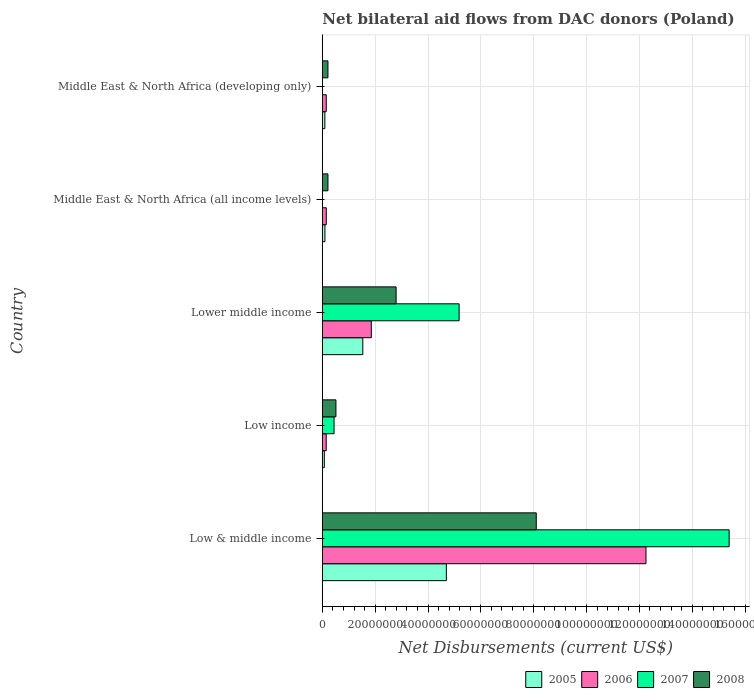Are the number of bars on each tick of the Y-axis equal?
Provide a succinct answer. No. How many bars are there on the 4th tick from the bottom?
Keep it short and to the point. 3. What is the label of the 2nd group of bars from the top?
Give a very brief answer. Middle East & North Africa (all income levels). In how many cases, is the number of bars for a given country not equal to the number of legend labels?
Your response must be concise. 2. What is the net bilateral aid flows in 2008 in Low & middle income?
Give a very brief answer. 8.10e+07. Across all countries, what is the maximum net bilateral aid flows in 2006?
Make the answer very short. 1.23e+08. What is the total net bilateral aid flows in 2005 in the graph?
Give a very brief answer. 6.50e+07. What is the difference between the net bilateral aid flows in 2005 in Low & middle income and that in Low income?
Make the answer very short. 4.62e+07. What is the difference between the net bilateral aid flows in 2008 in Low income and the net bilateral aid flows in 2005 in Low & middle income?
Your answer should be compact. -4.18e+07. What is the average net bilateral aid flows in 2007 per country?
Your answer should be very brief. 4.20e+07. What is the difference between the net bilateral aid flows in 2007 and net bilateral aid flows in 2008 in Low & middle income?
Offer a terse response. 7.30e+07. In how many countries, is the net bilateral aid flows in 2007 greater than 28000000 US$?
Your response must be concise. 2. What is the ratio of the net bilateral aid flows in 2006 in Low & middle income to that in Middle East & North Africa (all income levels)?
Offer a very short reply. 81.67. What is the difference between the highest and the second highest net bilateral aid flows in 2005?
Your answer should be compact. 3.16e+07. What is the difference between the highest and the lowest net bilateral aid flows in 2005?
Give a very brief answer. 4.62e+07. Is the sum of the net bilateral aid flows in 2008 in Low income and Middle East & North Africa (developing only) greater than the maximum net bilateral aid flows in 2007 across all countries?
Provide a succinct answer. No. Does the graph contain any zero values?
Provide a succinct answer. Yes. Does the graph contain grids?
Your response must be concise. Yes. What is the title of the graph?
Give a very brief answer. Net bilateral aid flows from DAC donors (Poland). Does "1963" appear as one of the legend labels in the graph?
Ensure brevity in your answer.  No. What is the label or title of the X-axis?
Keep it short and to the point. Net Disbursements (current US$). What is the Net Disbursements (current US$) of 2005 in Low & middle income?
Offer a terse response. 4.69e+07. What is the Net Disbursements (current US$) in 2006 in Low & middle income?
Your answer should be compact. 1.23e+08. What is the Net Disbursements (current US$) in 2007 in Low & middle income?
Provide a succinct answer. 1.54e+08. What is the Net Disbursements (current US$) in 2008 in Low & middle income?
Ensure brevity in your answer.  8.10e+07. What is the Net Disbursements (current US$) in 2005 in Low income?
Offer a terse response. 7.50e+05. What is the Net Disbursements (current US$) of 2006 in Low income?
Provide a short and direct response. 1.47e+06. What is the Net Disbursements (current US$) of 2007 in Low income?
Ensure brevity in your answer.  4.44e+06. What is the Net Disbursements (current US$) in 2008 in Low income?
Provide a short and direct response. 5.15e+06. What is the Net Disbursements (current US$) in 2005 in Lower middle income?
Make the answer very short. 1.53e+07. What is the Net Disbursements (current US$) of 2006 in Lower middle income?
Give a very brief answer. 1.85e+07. What is the Net Disbursements (current US$) of 2007 in Lower middle income?
Make the answer very short. 5.18e+07. What is the Net Disbursements (current US$) of 2008 in Lower middle income?
Ensure brevity in your answer.  2.79e+07. What is the Net Disbursements (current US$) in 2005 in Middle East & North Africa (all income levels)?
Offer a very short reply. 9.90e+05. What is the Net Disbursements (current US$) of 2006 in Middle East & North Africa (all income levels)?
Offer a very short reply. 1.50e+06. What is the Net Disbursements (current US$) of 2007 in Middle East & North Africa (all income levels)?
Offer a very short reply. 0. What is the Net Disbursements (current US$) in 2008 in Middle East & North Africa (all income levels)?
Ensure brevity in your answer.  2.13e+06. What is the Net Disbursements (current US$) of 2005 in Middle East & North Africa (developing only)?
Keep it short and to the point. 9.60e+05. What is the Net Disbursements (current US$) of 2006 in Middle East & North Africa (developing only)?
Offer a terse response. 1.49e+06. What is the Net Disbursements (current US$) in 2008 in Middle East & North Africa (developing only)?
Your answer should be compact. 2.13e+06. Across all countries, what is the maximum Net Disbursements (current US$) in 2005?
Keep it short and to the point. 4.69e+07. Across all countries, what is the maximum Net Disbursements (current US$) of 2006?
Give a very brief answer. 1.23e+08. Across all countries, what is the maximum Net Disbursements (current US$) of 2007?
Offer a terse response. 1.54e+08. Across all countries, what is the maximum Net Disbursements (current US$) of 2008?
Provide a short and direct response. 8.10e+07. Across all countries, what is the minimum Net Disbursements (current US$) of 2005?
Your answer should be compact. 7.50e+05. Across all countries, what is the minimum Net Disbursements (current US$) of 2006?
Provide a short and direct response. 1.47e+06. Across all countries, what is the minimum Net Disbursements (current US$) of 2007?
Your answer should be very brief. 0. Across all countries, what is the minimum Net Disbursements (current US$) in 2008?
Your response must be concise. 2.13e+06. What is the total Net Disbursements (current US$) in 2005 in the graph?
Your response must be concise. 6.50e+07. What is the total Net Disbursements (current US$) of 2006 in the graph?
Offer a very short reply. 1.46e+08. What is the total Net Disbursements (current US$) of 2007 in the graph?
Offer a very short reply. 2.10e+08. What is the total Net Disbursements (current US$) of 2008 in the graph?
Ensure brevity in your answer.  1.18e+08. What is the difference between the Net Disbursements (current US$) of 2005 in Low & middle income and that in Low income?
Make the answer very short. 4.62e+07. What is the difference between the Net Disbursements (current US$) of 2006 in Low & middle income and that in Low income?
Offer a terse response. 1.21e+08. What is the difference between the Net Disbursements (current US$) of 2007 in Low & middle income and that in Low income?
Your answer should be compact. 1.50e+08. What is the difference between the Net Disbursements (current US$) of 2008 in Low & middle income and that in Low income?
Your response must be concise. 7.58e+07. What is the difference between the Net Disbursements (current US$) of 2005 in Low & middle income and that in Lower middle income?
Your answer should be compact. 3.16e+07. What is the difference between the Net Disbursements (current US$) in 2006 in Low & middle income and that in Lower middle income?
Your response must be concise. 1.04e+08. What is the difference between the Net Disbursements (current US$) in 2007 in Low & middle income and that in Lower middle income?
Ensure brevity in your answer.  1.02e+08. What is the difference between the Net Disbursements (current US$) of 2008 in Low & middle income and that in Lower middle income?
Offer a terse response. 5.30e+07. What is the difference between the Net Disbursements (current US$) in 2005 in Low & middle income and that in Middle East & North Africa (all income levels)?
Provide a short and direct response. 4.60e+07. What is the difference between the Net Disbursements (current US$) in 2006 in Low & middle income and that in Middle East & North Africa (all income levels)?
Offer a terse response. 1.21e+08. What is the difference between the Net Disbursements (current US$) of 2008 in Low & middle income and that in Middle East & North Africa (all income levels)?
Provide a short and direct response. 7.88e+07. What is the difference between the Net Disbursements (current US$) in 2005 in Low & middle income and that in Middle East & North Africa (developing only)?
Your answer should be very brief. 4.60e+07. What is the difference between the Net Disbursements (current US$) in 2006 in Low & middle income and that in Middle East & North Africa (developing only)?
Your response must be concise. 1.21e+08. What is the difference between the Net Disbursements (current US$) of 2008 in Low & middle income and that in Middle East & North Africa (developing only)?
Make the answer very short. 7.88e+07. What is the difference between the Net Disbursements (current US$) in 2005 in Low income and that in Lower middle income?
Give a very brief answer. -1.46e+07. What is the difference between the Net Disbursements (current US$) in 2006 in Low income and that in Lower middle income?
Your answer should be very brief. -1.71e+07. What is the difference between the Net Disbursements (current US$) in 2007 in Low income and that in Lower middle income?
Provide a succinct answer. -4.73e+07. What is the difference between the Net Disbursements (current US$) in 2008 in Low income and that in Lower middle income?
Offer a very short reply. -2.28e+07. What is the difference between the Net Disbursements (current US$) in 2005 in Low income and that in Middle East & North Africa (all income levels)?
Provide a short and direct response. -2.40e+05. What is the difference between the Net Disbursements (current US$) in 2006 in Low income and that in Middle East & North Africa (all income levels)?
Provide a short and direct response. -3.00e+04. What is the difference between the Net Disbursements (current US$) in 2008 in Low income and that in Middle East & North Africa (all income levels)?
Your answer should be very brief. 3.02e+06. What is the difference between the Net Disbursements (current US$) of 2008 in Low income and that in Middle East & North Africa (developing only)?
Provide a short and direct response. 3.02e+06. What is the difference between the Net Disbursements (current US$) of 2005 in Lower middle income and that in Middle East & North Africa (all income levels)?
Your response must be concise. 1.43e+07. What is the difference between the Net Disbursements (current US$) in 2006 in Lower middle income and that in Middle East & North Africa (all income levels)?
Ensure brevity in your answer.  1.70e+07. What is the difference between the Net Disbursements (current US$) of 2008 in Lower middle income and that in Middle East & North Africa (all income levels)?
Provide a succinct answer. 2.58e+07. What is the difference between the Net Disbursements (current US$) of 2005 in Lower middle income and that in Middle East & North Africa (developing only)?
Offer a very short reply. 1.44e+07. What is the difference between the Net Disbursements (current US$) of 2006 in Lower middle income and that in Middle East & North Africa (developing only)?
Provide a succinct answer. 1.70e+07. What is the difference between the Net Disbursements (current US$) of 2008 in Lower middle income and that in Middle East & North Africa (developing only)?
Your answer should be compact. 2.58e+07. What is the difference between the Net Disbursements (current US$) in 2005 in Middle East & North Africa (all income levels) and that in Middle East & North Africa (developing only)?
Offer a terse response. 3.00e+04. What is the difference between the Net Disbursements (current US$) in 2006 in Middle East & North Africa (all income levels) and that in Middle East & North Africa (developing only)?
Your answer should be very brief. 10000. What is the difference between the Net Disbursements (current US$) in 2005 in Low & middle income and the Net Disbursements (current US$) in 2006 in Low income?
Offer a terse response. 4.55e+07. What is the difference between the Net Disbursements (current US$) in 2005 in Low & middle income and the Net Disbursements (current US$) in 2007 in Low income?
Provide a short and direct response. 4.25e+07. What is the difference between the Net Disbursements (current US$) of 2005 in Low & middle income and the Net Disbursements (current US$) of 2008 in Low income?
Your answer should be very brief. 4.18e+07. What is the difference between the Net Disbursements (current US$) of 2006 in Low & middle income and the Net Disbursements (current US$) of 2007 in Low income?
Your answer should be compact. 1.18e+08. What is the difference between the Net Disbursements (current US$) in 2006 in Low & middle income and the Net Disbursements (current US$) in 2008 in Low income?
Make the answer very short. 1.17e+08. What is the difference between the Net Disbursements (current US$) in 2007 in Low & middle income and the Net Disbursements (current US$) in 2008 in Low income?
Offer a very short reply. 1.49e+08. What is the difference between the Net Disbursements (current US$) in 2005 in Low & middle income and the Net Disbursements (current US$) in 2006 in Lower middle income?
Your answer should be very brief. 2.84e+07. What is the difference between the Net Disbursements (current US$) of 2005 in Low & middle income and the Net Disbursements (current US$) of 2007 in Lower middle income?
Your answer should be compact. -4.84e+06. What is the difference between the Net Disbursements (current US$) of 2005 in Low & middle income and the Net Disbursements (current US$) of 2008 in Lower middle income?
Provide a short and direct response. 1.90e+07. What is the difference between the Net Disbursements (current US$) in 2006 in Low & middle income and the Net Disbursements (current US$) in 2007 in Lower middle income?
Keep it short and to the point. 7.07e+07. What is the difference between the Net Disbursements (current US$) of 2006 in Low & middle income and the Net Disbursements (current US$) of 2008 in Lower middle income?
Give a very brief answer. 9.46e+07. What is the difference between the Net Disbursements (current US$) in 2007 in Low & middle income and the Net Disbursements (current US$) in 2008 in Lower middle income?
Make the answer very short. 1.26e+08. What is the difference between the Net Disbursements (current US$) of 2005 in Low & middle income and the Net Disbursements (current US$) of 2006 in Middle East & North Africa (all income levels)?
Provide a short and direct response. 4.54e+07. What is the difference between the Net Disbursements (current US$) of 2005 in Low & middle income and the Net Disbursements (current US$) of 2008 in Middle East & North Africa (all income levels)?
Provide a short and direct response. 4.48e+07. What is the difference between the Net Disbursements (current US$) in 2006 in Low & middle income and the Net Disbursements (current US$) in 2008 in Middle East & North Africa (all income levels)?
Your answer should be compact. 1.20e+08. What is the difference between the Net Disbursements (current US$) in 2007 in Low & middle income and the Net Disbursements (current US$) in 2008 in Middle East & North Africa (all income levels)?
Offer a terse response. 1.52e+08. What is the difference between the Net Disbursements (current US$) of 2005 in Low & middle income and the Net Disbursements (current US$) of 2006 in Middle East & North Africa (developing only)?
Your response must be concise. 4.54e+07. What is the difference between the Net Disbursements (current US$) in 2005 in Low & middle income and the Net Disbursements (current US$) in 2008 in Middle East & North Africa (developing only)?
Offer a very short reply. 4.48e+07. What is the difference between the Net Disbursements (current US$) in 2006 in Low & middle income and the Net Disbursements (current US$) in 2008 in Middle East & North Africa (developing only)?
Offer a very short reply. 1.20e+08. What is the difference between the Net Disbursements (current US$) of 2007 in Low & middle income and the Net Disbursements (current US$) of 2008 in Middle East & North Africa (developing only)?
Give a very brief answer. 1.52e+08. What is the difference between the Net Disbursements (current US$) of 2005 in Low income and the Net Disbursements (current US$) of 2006 in Lower middle income?
Offer a very short reply. -1.78e+07. What is the difference between the Net Disbursements (current US$) of 2005 in Low income and the Net Disbursements (current US$) of 2007 in Lower middle income?
Ensure brevity in your answer.  -5.10e+07. What is the difference between the Net Disbursements (current US$) of 2005 in Low income and the Net Disbursements (current US$) of 2008 in Lower middle income?
Provide a short and direct response. -2.72e+07. What is the difference between the Net Disbursements (current US$) of 2006 in Low income and the Net Disbursements (current US$) of 2007 in Lower middle income?
Keep it short and to the point. -5.03e+07. What is the difference between the Net Disbursements (current US$) in 2006 in Low income and the Net Disbursements (current US$) in 2008 in Lower middle income?
Give a very brief answer. -2.65e+07. What is the difference between the Net Disbursements (current US$) of 2007 in Low income and the Net Disbursements (current US$) of 2008 in Lower middle income?
Your response must be concise. -2.35e+07. What is the difference between the Net Disbursements (current US$) of 2005 in Low income and the Net Disbursements (current US$) of 2006 in Middle East & North Africa (all income levels)?
Your answer should be compact. -7.50e+05. What is the difference between the Net Disbursements (current US$) of 2005 in Low income and the Net Disbursements (current US$) of 2008 in Middle East & North Africa (all income levels)?
Offer a very short reply. -1.38e+06. What is the difference between the Net Disbursements (current US$) in 2006 in Low income and the Net Disbursements (current US$) in 2008 in Middle East & North Africa (all income levels)?
Provide a succinct answer. -6.60e+05. What is the difference between the Net Disbursements (current US$) of 2007 in Low income and the Net Disbursements (current US$) of 2008 in Middle East & North Africa (all income levels)?
Provide a succinct answer. 2.31e+06. What is the difference between the Net Disbursements (current US$) of 2005 in Low income and the Net Disbursements (current US$) of 2006 in Middle East & North Africa (developing only)?
Your answer should be compact. -7.40e+05. What is the difference between the Net Disbursements (current US$) in 2005 in Low income and the Net Disbursements (current US$) in 2008 in Middle East & North Africa (developing only)?
Keep it short and to the point. -1.38e+06. What is the difference between the Net Disbursements (current US$) of 2006 in Low income and the Net Disbursements (current US$) of 2008 in Middle East & North Africa (developing only)?
Provide a short and direct response. -6.60e+05. What is the difference between the Net Disbursements (current US$) in 2007 in Low income and the Net Disbursements (current US$) in 2008 in Middle East & North Africa (developing only)?
Your response must be concise. 2.31e+06. What is the difference between the Net Disbursements (current US$) of 2005 in Lower middle income and the Net Disbursements (current US$) of 2006 in Middle East & North Africa (all income levels)?
Keep it short and to the point. 1.38e+07. What is the difference between the Net Disbursements (current US$) in 2005 in Lower middle income and the Net Disbursements (current US$) in 2008 in Middle East & North Africa (all income levels)?
Ensure brevity in your answer.  1.32e+07. What is the difference between the Net Disbursements (current US$) in 2006 in Lower middle income and the Net Disbursements (current US$) in 2008 in Middle East & North Africa (all income levels)?
Make the answer very short. 1.64e+07. What is the difference between the Net Disbursements (current US$) of 2007 in Lower middle income and the Net Disbursements (current US$) of 2008 in Middle East & North Africa (all income levels)?
Your response must be concise. 4.96e+07. What is the difference between the Net Disbursements (current US$) in 2005 in Lower middle income and the Net Disbursements (current US$) in 2006 in Middle East & North Africa (developing only)?
Offer a terse response. 1.38e+07. What is the difference between the Net Disbursements (current US$) in 2005 in Lower middle income and the Net Disbursements (current US$) in 2008 in Middle East & North Africa (developing only)?
Keep it short and to the point. 1.32e+07. What is the difference between the Net Disbursements (current US$) of 2006 in Lower middle income and the Net Disbursements (current US$) of 2008 in Middle East & North Africa (developing only)?
Keep it short and to the point. 1.64e+07. What is the difference between the Net Disbursements (current US$) of 2007 in Lower middle income and the Net Disbursements (current US$) of 2008 in Middle East & North Africa (developing only)?
Provide a short and direct response. 4.96e+07. What is the difference between the Net Disbursements (current US$) in 2005 in Middle East & North Africa (all income levels) and the Net Disbursements (current US$) in 2006 in Middle East & North Africa (developing only)?
Provide a short and direct response. -5.00e+05. What is the difference between the Net Disbursements (current US$) of 2005 in Middle East & North Africa (all income levels) and the Net Disbursements (current US$) of 2008 in Middle East & North Africa (developing only)?
Keep it short and to the point. -1.14e+06. What is the difference between the Net Disbursements (current US$) in 2006 in Middle East & North Africa (all income levels) and the Net Disbursements (current US$) in 2008 in Middle East & North Africa (developing only)?
Provide a succinct answer. -6.30e+05. What is the average Net Disbursements (current US$) in 2005 per country?
Give a very brief answer. 1.30e+07. What is the average Net Disbursements (current US$) of 2006 per country?
Your response must be concise. 2.91e+07. What is the average Net Disbursements (current US$) in 2007 per country?
Offer a terse response. 4.20e+07. What is the average Net Disbursements (current US$) in 2008 per country?
Make the answer very short. 2.37e+07. What is the difference between the Net Disbursements (current US$) of 2005 and Net Disbursements (current US$) of 2006 in Low & middle income?
Provide a succinct answer. -7.56e+07. What is the difference between the Net Disbursements (current US$) of 2005 and Net Disbursements (current US$) of 2007 in Low & middle income?
Ensure brevity in your answer.  -1.07e+08. What is the difference between the Net Disbursements (current US$) in 2005 and Net Disbursements (current US$) in 2008 in Low & middle income?
Provide a short and direct response. -3.40e+07. What is the difference between the Net Disbursements (current US$) of 2006 and Net Disbursements (current US$) of 2007 in Low & middle income?
Provide a succinct answer. -3.15e+07. What is the difference between the Net Disbursements (current US$) of 2006 and Net Disbursements (current US$) of 2008 in Low & middle income?
Offer a terse response. 4.15e+07. What is the difference between the Net Disbursements (current US$) of 2007 and Net Disbursements (current US$) of 2008 in Low & middle income?
Offer a terse response. 7.30e+07. What is the difference between the Net Disbursements (current US$) of 2005 and Net Disbursements (current US$) of 2006 in Low income?
Keep it short and to the point. -7.20e+05. What is the difference between the Net Disbursements (current US$) of 2005 and Net Disbursements (current US$) of 2007 in Low income?
Provide a short and direct response. -3.69e+06. What is the difference between the Net Disbursements (current US$) of 2005 and Net Disbursements (current US$) of 2008 in Low income?
Your response must be concise. -4.40e+06. What is the difference between the Net Disbursements (current US$) of 2006 and Net Disbursements (current US$) of 2007 in Low income?
Your answer should be compact. -2.97e+06. What is the difference between the Net Disbursements (current US$) of 2006 and Net Disbursements (current US$) of 2008 in Low income?
Provide a short and direct response. -3.68e+06. What is the difference between the Net Disbursements (current US$) of 2007 and Net Disbursements (current US$) of 2008 in Low income?
Offer a very short reply. -7.10e+05. What is the difference between the Net Disbursements (current US$) in 2005 and Net Disbursements (current US$) in 2006 in Lower middle income?
Offer a terse response. -3.22e+06. What is the difference between the Net Disbursements (current US$) in 2005 and Net Disbursements (current US$) in 2007 in Lower middle income?
Offer a very short reply. -3.65e+07. What is the difference between the Net Disbursements (current US$) of 2005 and Net Disbursements (current US$) of 2008 in Lower middle income?
Your answer should be compact. -1.26e+07. What is the difference between the Net Disbursements (current US$) in 2006 and Net Disbursements (current US$) in 2007 in Lower middle income?
Offer a terse response. -3.32e+07. What is the difference between the Net Disbursements (current US$) of 2006 and Net Disbursements (current US$) of 2008 in Lower middle income?
Offer a very short reply. -9.39e+06. What is the difference between the Net Disbursements (current US$) in 2007 and Net Disbursements (current US$) in 2008 in Lower middle income?
Offer a very short reply. 2.38e+07. What is the difference between the Net Disbursements (current US$) of 2005 and Net Disbursements (current US$) of 2006 in Middle East & North Africa (all income levels)?
Provide a short and direct response. -5.10e+05. What is the difference between the Net Disbursements (current US$) in 2005 and Net Disbursements (current US$) in 2008 in Middle East & North Africa (all income levels)?
Your response must be concise. -1.14e+06. What is the difference between the Net Disbursements (current US$) of 2006 and Net Disbursements (current US$) of 2008 in Middle East & North Africa (all income levels)?
Offer a very short reply. -6.30e+05. What is the difference between the Net Disbursements (current US$) of 2005 and Net Disbursements (current US$) of 2006 in Middle East & North Africa (developing only)?
Keep it short and to the point. -5.30e+05. What is the difference between the Net Disbursements (current US$) in 2005 and Net Disbursements (current US$) in 2008 in Middle East & North Africa (developing only)?
Your answer should be very brief. -1.17e+06. What is the difference between the Net Disbursements (current US$) in 2006 and Net Disbursements (current US$) in 2008 in Middle East & North Africa (developing only)?
Your response must be concise. -6.40e+05. What is the ratio of the Net Disbursements (current US$) in 2005 in Low & middle income to that in Low income?
Offer a terse response. 62.59. What is the ratio of the Net Disbursements (current US$) in 2006 in Low & middle income to that in Low income?
Offer a terse response. 83.34. What is the ratio of the Net Disbursements (current US$) of 2007 in Low & middle income to that in Low income?
Your response must be concise. 34.68. What is the ratio of the Net Disbursements (current US$) in 2008 in Low & middle income to that in Low income?
Provide a short and direct response. 15.72. What is the ratio of the Net Disbursements (current US$) in 2005 in Low & middle income to that in Lower middle income?
Make the answer very short. 3.06. What is the ratio of the Net Disbursements (current US$) of 2006 in Low & middle income to that in Lower middle income?
Ensure brevity in your answer.  6.61. What is the ratio of the Net Disbursements (current US$) in 2007 in Low & middle income to that in Lower middle income?
Your answer should be very brief. 2.97. What is the ratio of the Net Disbursements (current US$) in 2008 in Low & middle income to that in Lower middle income?
Your response must be concise. 2.9. What is the ratio of the Net Disbursements (current US$) of 2005 in Low & middle income to that in Middle East & North Africa (all income levels)?
Your answer should be compact. 47.41. What is the ratio of the Net Disbursements (current US$) of 2006 in Low & middle income to that in Middle East & North Africa (all income levels)?
Provide a short and direct response. 81.67. What is the ratio of the Net Disbursements (current US$) of 2008 in Low & middle income to that in Middle East & North Africa (all income levels)?
Make the answer very short. 38.02. What is the ratio of the Net Disbursements (current US$) of 2005 in Low & middle income to that in Middle East & North Africa (developing only)?
Your answer should be compact. 48.9. What is the ratio of the Net Disbursements (current US$) of 2006 in Low & middle income to that in Middle East & North Africa (developing only)?
Your answer should be compact. 82.22. What is the ratio of the Net Disbursements (current US$) in 2008 in Low & middle income to that in Middle East & North Africa (developing only)?
Offer a terse response. 38.02. What is the ratio of the Net Disbursements (current US$) of 2005 in Low income to that in Lower middle income?
Offer a terse response. 0.05. What is the ratio of the Net Disbursements (current US$) of 2006 in Low income to that in Lower middle income?
Your response must be concise. 0.08. What is the ratio of the Net Disbursements (current US$) of 2007 in Low income to that in Lower middle income?
Provide a succinct answer. 0.09. What is the ratio of the Net Disbursements (current US$) in 2008 in Low income to that in Lower middle income?
Give a very brief answer. 0.18. What is the ratio of the Net Disbursements (current US$) in 2005 in Low income to that in Middle East & North Africa (all income levels)?
Your response must be concise. 0.76. What is the ratio of the Net Disbursements (current US$) in 2006 in Low income to that in Middle East & North Africa (all income levels)?
Provide a succinct answer. 0.98. What is the ratio of the Net Disbursements (current US$) in 2008 in Low income to that in Middle East & North Africa (all income levels)?
Your answer should be very brief. 2.42. What is the ratio of the Net Disbursements (current US$) of 2005 in Low income to that in Middle East & North Africa (developing only)?
Ensure brevity in your answer.  0.78. What is the ratio of the Net Disbursements (current US$) in 2006 in Low income to that in Middle East & North Africa (developing only)?
Provide a succinct answer. 0.99. What is the ratio of the Net Disbursements (current US$) in 2008 in Low income to that in Middle East & North Africa (developing only)?
Your response must be concise. 2.42. What is the ratio of the Net Disbursements (current US$) of 2005 in Lower middle income to that in Middle East & North Africa (all income levels)?
Make the answer very short. 15.47. What is the ratio of the Net Disbursements (current US$) in 2006 in Lower middle income to that in Middle East & North Africa (all income levels)?
Your response must be concise. 12.36. What is the ratio of the Net Disbursements (current US$) of 2008 in Lower middle income to that in Middle East & North Africa (all income levels)?
Ensure brevity in your answer.  13.11. What is the ratio of the Net Disbursements (current US$) of 2005 in Lower middle income to that in Middle East & North Africa (developing only)?
Provide a short and direct response. 15.96. What is the ratio of the Net Disbursements (current US$) in 2006 in Lower middle income to that in Middle East & North Africa (developing only)?
Provide a succinct answer. 12.44. What is the ratio of the Net Disbursements (current US$) of 2008 in Lower middle income to that in Middle East & North Africa (developing only)?
Offer a very short reply. 13.11. What is the ratio of the Net Disbursements (current US$) of 2005 in Middle East & North Africa (all income levels) to that in Middle East & North Africa (developing only)?
Your answer should be compact. 1.03. What is the ratio of the Net Disbursements (current US$) in 2008 in Middle East & North Africa (all income levels) to that in Middle East & North Africa (developing only)?
Your answer should be compact. 1. What is the difference between the highest and the second highest Net Disbursements (current US$) in 2005?
Offer a terse response. 3.16e+07. What is the difference between the highest and the second highest Net Disbursements (current US$) of 2006?
Provide a short and direct response. 1.04e+08. What is the difference between the highest and the second highest Net Disbursements (current US$) of 2007?
Your answer should be compact. 1.02e+08. What is the difference between the highest and the second highest Net Disbursements (current US$) of 2008?
Your answer should be very brief. 5.30e+07. What is the difference between the highest and the lowest Net Disbursements (current US$) of 2005?
Provide a short and direct response. 4.62e+07. What is the difference between the highest and the lowest Net Disbursements (current US$) of 2006?
Your answer should be compact. 1.21e+08. What is the difference between the highest and the lowest Net Disbursements (current US$) of 2007?
Provide a short and direct response. 1.54e+08. What is the difference between the highest and the lowest Net Disbursements (current US$) in 2008?
Your response must be concise. 7.88e+07. 